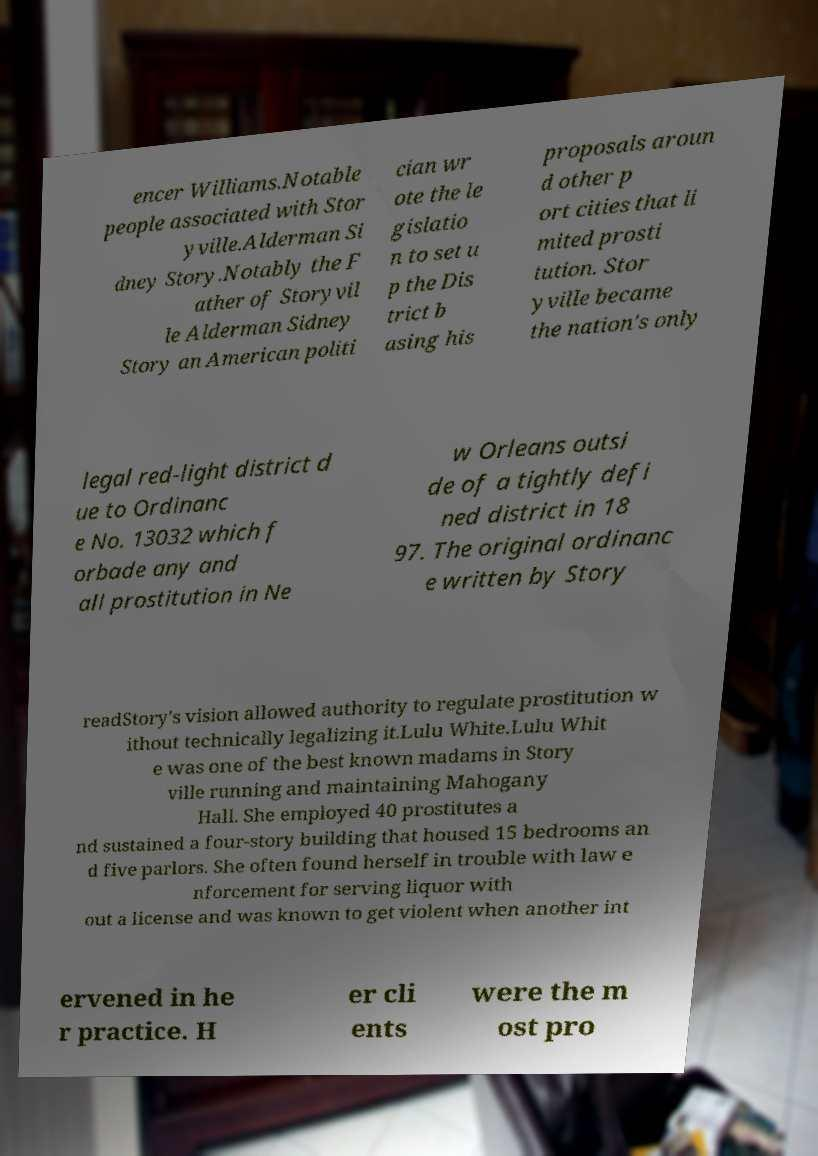Please identify and transcribe the text found in this image. encer Williams.Notable people associated with Stor yville.Alderman Si dney Story.Notably the F ather of Storyvil le Alderman Sidney Story an American politi cian wr ote the le gislatio n to set u p the Dis trict b asing his proposals aroun d other p ort cities that li mited prosti tution. Stor yville became the nation's only legal red-light district d ue to Ordinanc e No. 13032 which f orbade any and all prostitution in Ne w Orleans outsi de of a tightly defi ned district in 18 97. The original ordinanc e written by Story readStory's vision allowed authority to regulate prostitution w ithout technically legalizing it.Lulu White.Lulu Whit e was one of the best known madams in Story ville running and maintaining Mahogany Hall. She employed 40 prostitutes a nd sustained a four-story building that housed 15 bedrooms an d five parlors. She often found herself in trouble with law e nforcement for serving liquor with out a license and was known to get violent when another int ervened in he r practice. H er cli ents were the m ost pro 